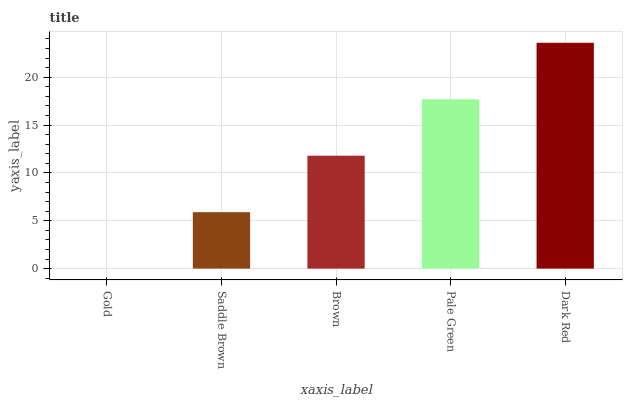Is Gold the minimum?
Answer yes or no. Yes. Is Dark Red the maximum?
Answer yes or no. Yes. Is Saddle Brown the minimum?
Answer yes or no. No. Is Saddle Brown the maximum?
Answer yes or no. No. Is Saddle Brown greater than Gold?
Answer yes or no. Yes. Is Gold less than Saddle Brown?
Answer yes or no. Yes. Is Gold greater than Saddle Brown?
Answer yes or no. No. Is Saddle Brown less than Gold?
Answer yes or no. No. Is Brown the high median?
Answer yes or no. Yes. Is Brown the low median?
Answer yes or no. Yes. Is Gold the high median?
Answer yes or no. No. Is Dark Red the low median?
Answer yes or no. No. 